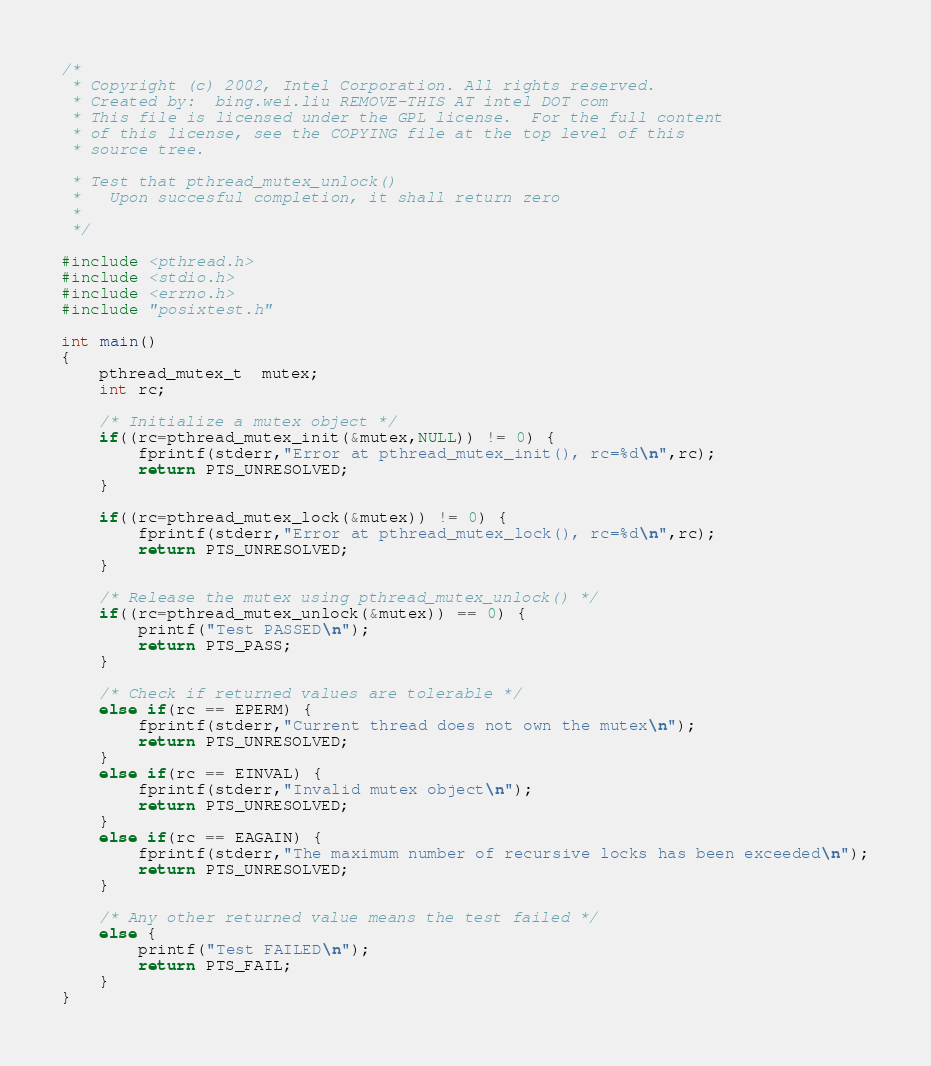<code> <loc_0><loc_0><loc_500><loc_500><_C_>/*   
 * Copyright (c) 2002, Intel Corporation. All rights reserved.
 * Created by:  bing.wei.liu REMOVE-THIS AT intel DOT com
 * This file is licensed under the GPL license.  For the full content
 * of this license, see the COPYING file at the top level of this 
 * source tree.

 * Test that pthread_mutex_unlock()
 *   Upon succesful completion, it shall return zero
 *
 */

#include <pthread.h>
#include <stdio.h>
#include <errno.h>
#include "posixtest.h"

int main()
{
	pthread_mutex_t  mutex;
	int rc;

	/* Initialize a mutex object */
	if((rc=pthread_mutex_init(&mutex,NULL)) != 0) {
		fprintf(stderr,"Error at pthread_mutex_init(), rc=%d\n",rc);
		return PTS_UNRESOLVED;
	}
	
	if((rc=pthread_mutex_lock(&mutex)) != 0) {
		fprintf(stderr,"Error at pthread_mutex_lock(), rc=%d\n",rc);
		return PTS_UNRESOLVED;
	}

	/* Release the mutex using pthread_mutex_unlock() */
	if((rc=pthread_mutex_unlock(&mutex)) == 0) {
		printf("Test PASSED\n");
		return PTS_PASS;
	}
	
	/* Check if returned values are tolerable */
	else if(rc == EPERM) {
		fprintf(stderr,"Current thread does not own the mutex\n");
		return PTS_UNRESOLVED;
	}
	else if(rc == EINVAL) {
		fprintf(stderr,"Invalid mutex object\n");
		return PTS_UNRESOLVED;
	}
	else if(rc == EAGAIN) {
		fprintf(stderr,"The maximum number of recursive locks has been exceeded\n");
		return PTS_UNRESOLVED;
	}

	/* Any other returned value means the test failed */
	else {
		printf("Test FAILED\n");
		return PTS_FAIL;
	}
}
</code> 